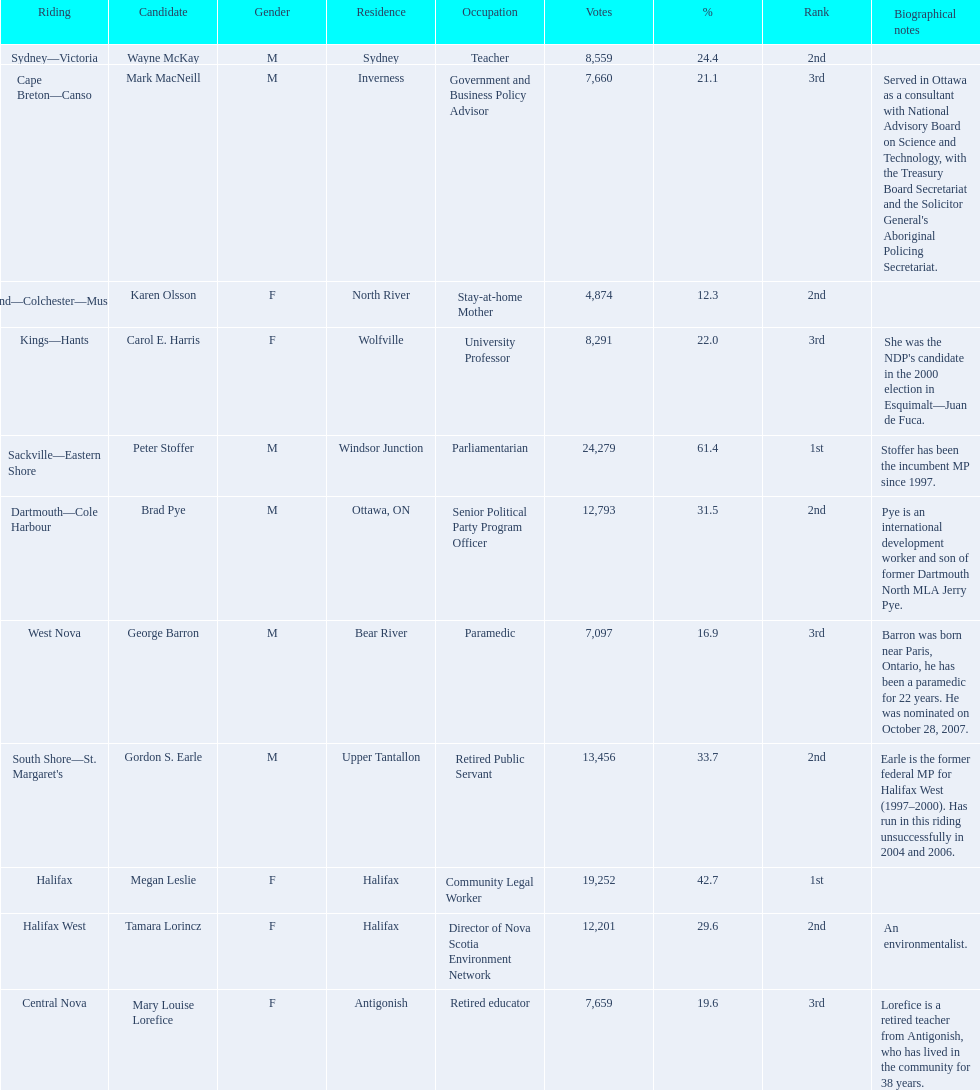Who has the most votes? Sackville-Eastern Shore. 